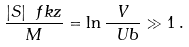<formula> <loc_0><loc_0><loc_500><loc_500>\frac { | S | \ f k z } { M } = \ln \frac { V } { \ U b } \gg 1 \, .</formula> 